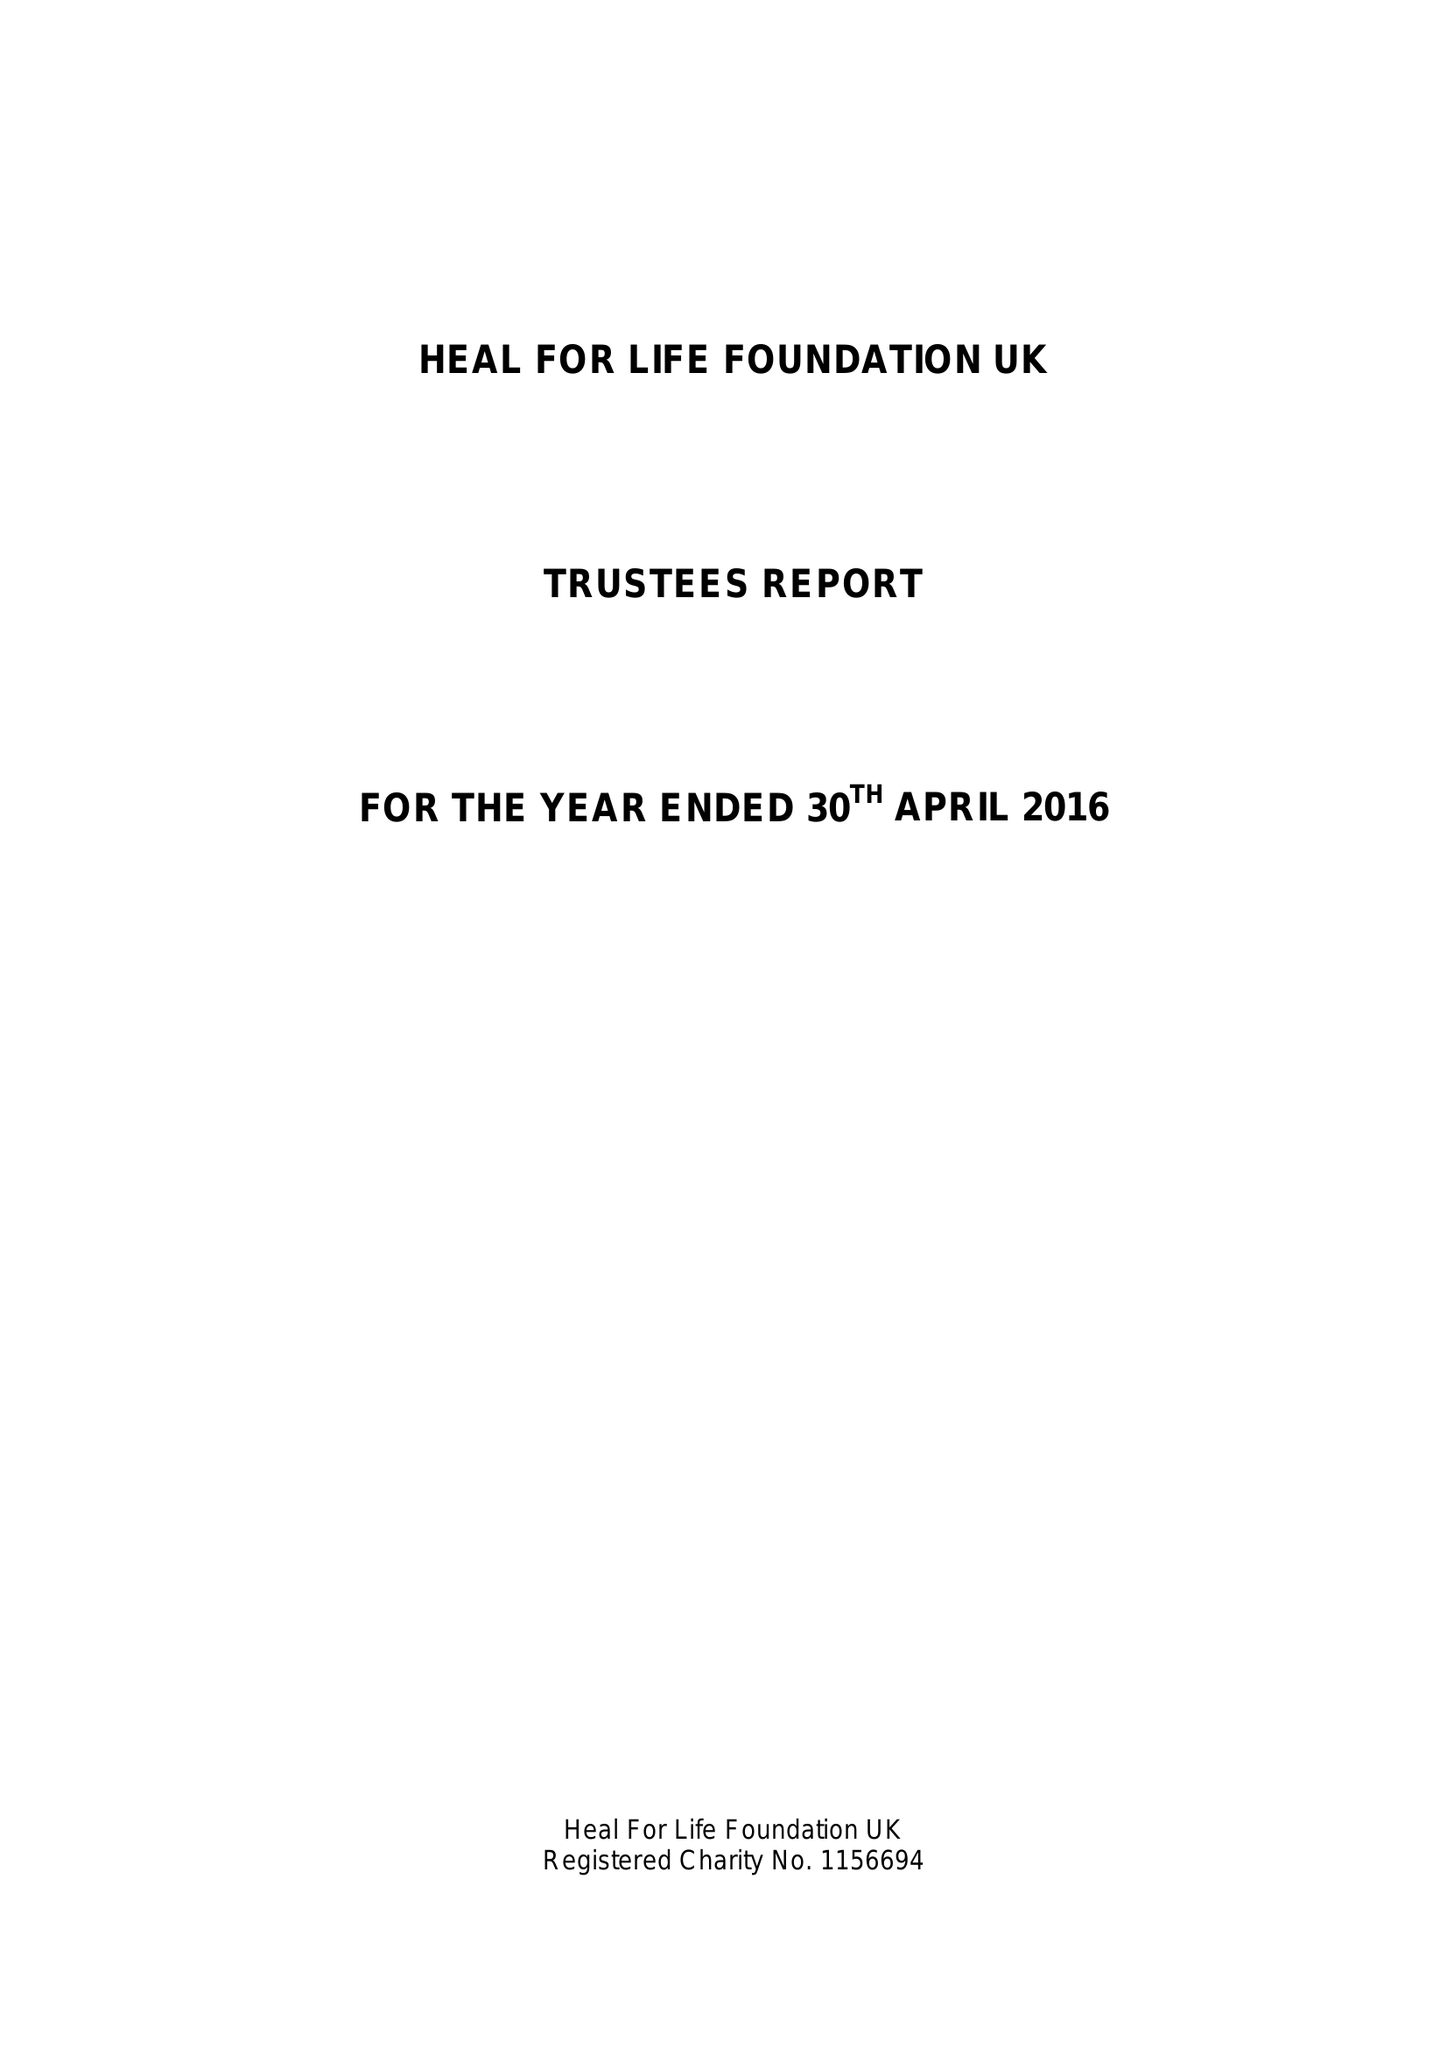What is the value for the charity_number?
Answer the question using a single word or phrase. 1156694 